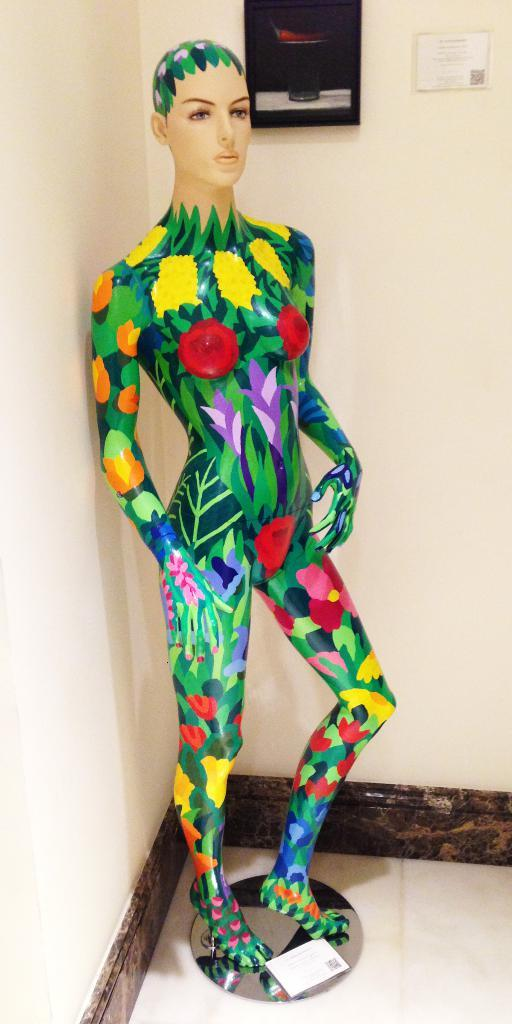What is the main subject of the image? The main subject of the image is a human statue. Can you describe the appearance of the human statue? The human statue has different colors. What else can be seen in the image besides the human statue? There is a wall in the image. What type of horn can be heard in the image? There is no horn present in the image, and therefore no sound can be heard. 